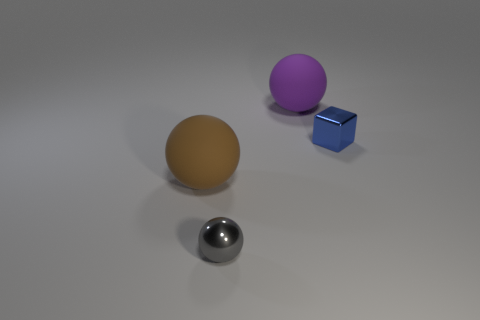What number of purple things have the same shape as the gray metal object?
Provide a short and direct response. 1. There is a object that is made of the same material as the big brown sphere; what is its size?
Offer a very short reply. Large. The thing that is both behind the small shiny ball and in front of the small blue thing is what color?
Offer a very short reply. Brown. How many metallic things have the same size as the shiny ball?
Make the answer very short. 1. What size is the ball that is both on the right side of the brown matte sphere and in front of the metallic block?
Provide a short and direct response. Small. There is a big sphere that is to the left of the tiny thing on the left side of the blue metallic cube; how many large spheres are behind it?
Your response must be concise. 1. Is there a matte thing that has the same color as the metallic cube?
Your answer should be compact. No. There is a object that is the same size as the block; what color is it?
Your answer should be compact. Gray. The shiny thing on the right side of the shiny object that is in front of the large matte ball that is left of the big purple thing is what shape?
Keep it short and to the point. Cube. There is a small thing that is in front of the blue object; how many big purple balls are behind it?
Provide a short and direct response. 1. 